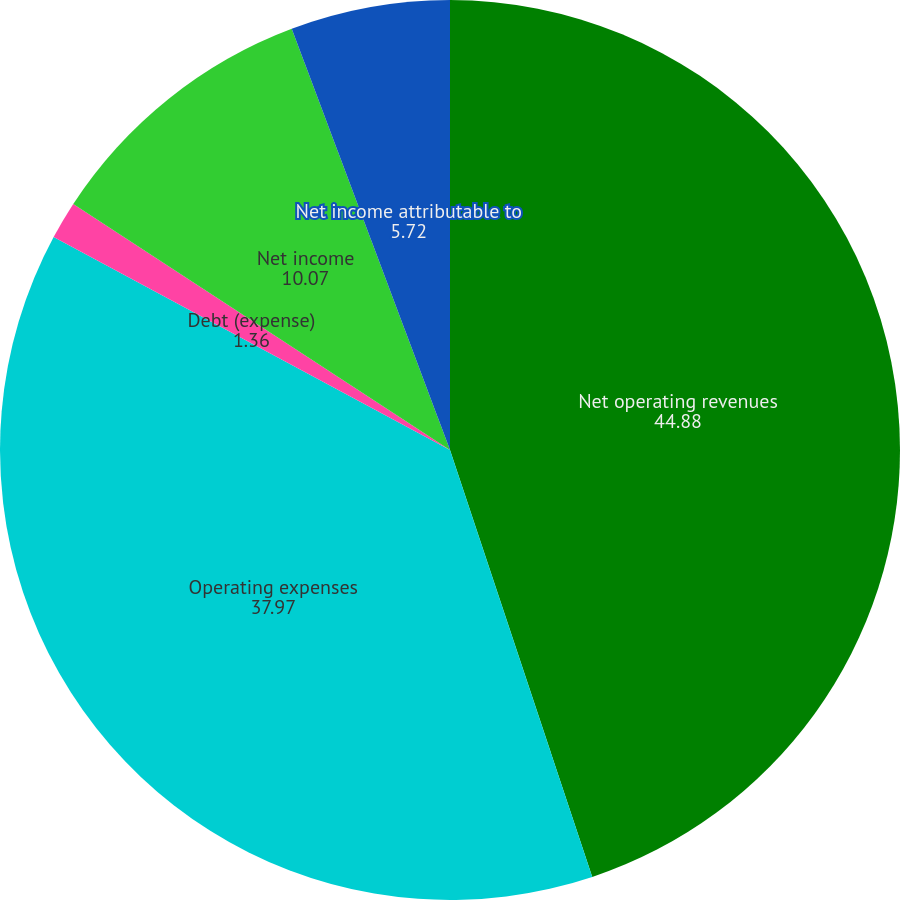Convert chart. <chart><loc_0><loc_0><loc_500><loc_500><pie_chart><fcel>Net operating revenues<fcel>Operating expenses<fcel>Debt (expense)<fcel>Net income<fcel>Net income attributable to<nl><fcel>44.88%<fcel>37.97%<fcel>1.36%<fcel>10.07%<fcel>5.72%<nl></chart> 